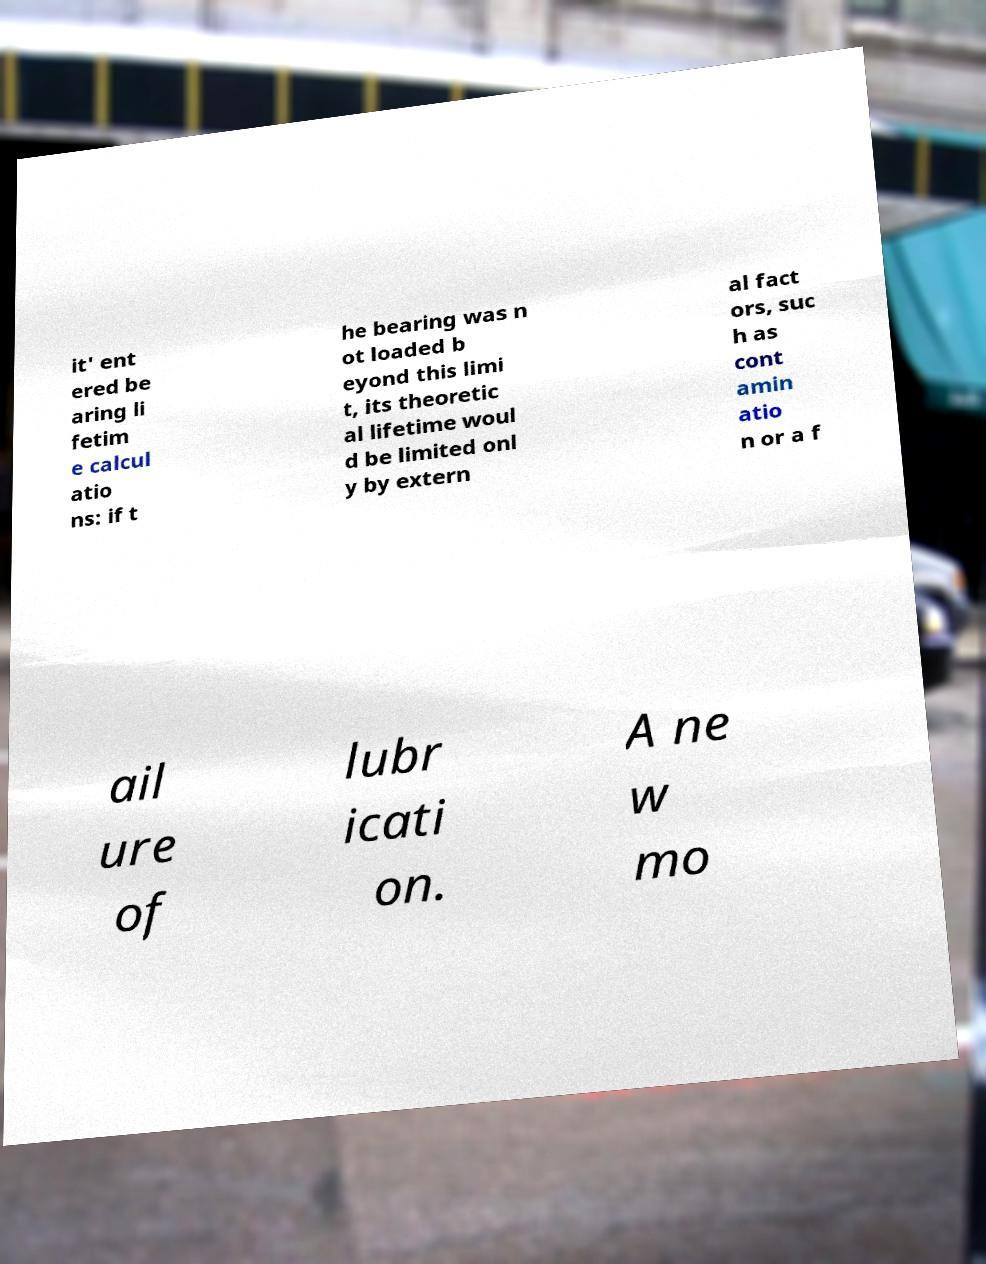Could you assist in decoding the text presented in this image and type it out clearly? it' ent ered be aring li fetim e calcul atio ns: if t he bearing was n ot loaded b eyond this limi t, its theoretic al lifetime woul d be limited onl y by extern al fact ors, suc h as cont amin atio n or a f ail ure of lubr icati on. A ne w mo 